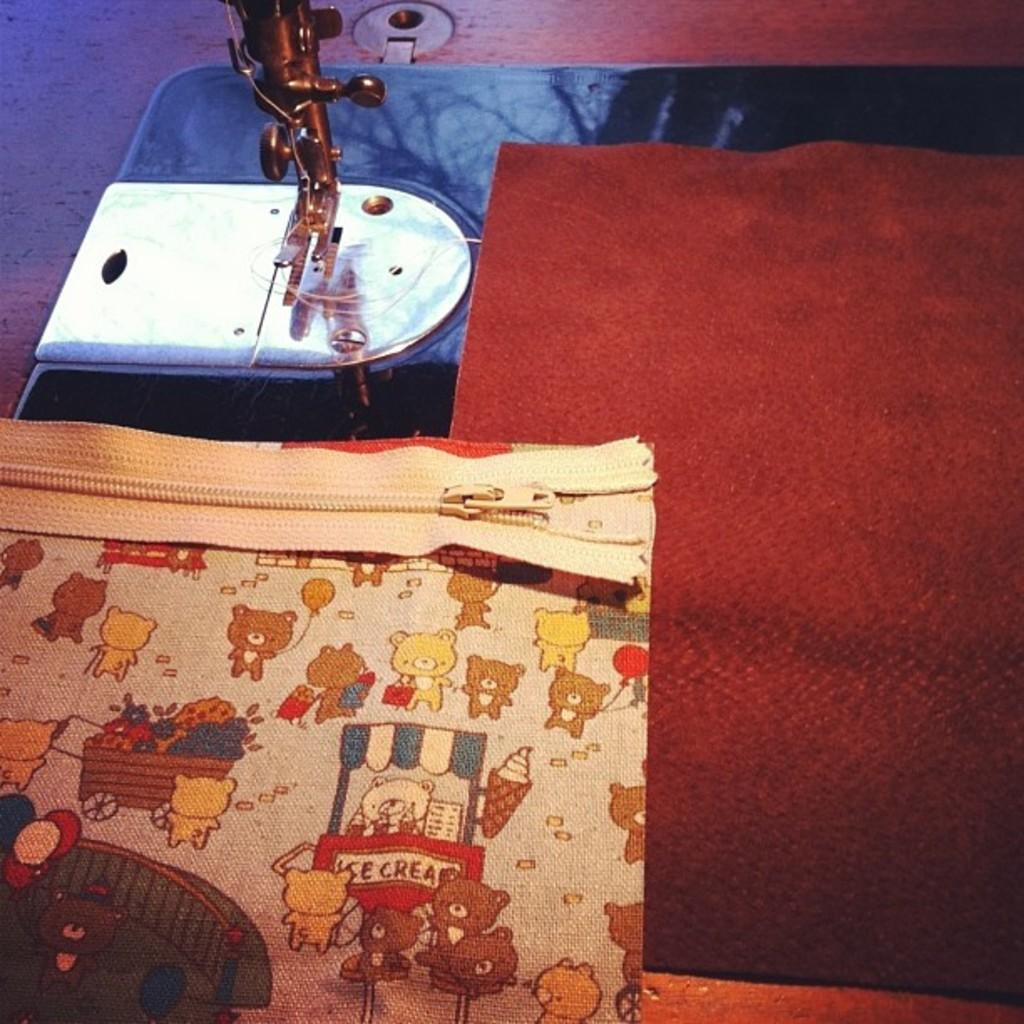What is placed on the sewing machine in the image? There is a cloth on the sewing machine in the image. What type of club can be seen in the image? There is no club present in the image; it features a cloth on a sewing machine. What kind of stamp is visible on the cloth in the image? There is no stamp visible on the cloth in the image. 